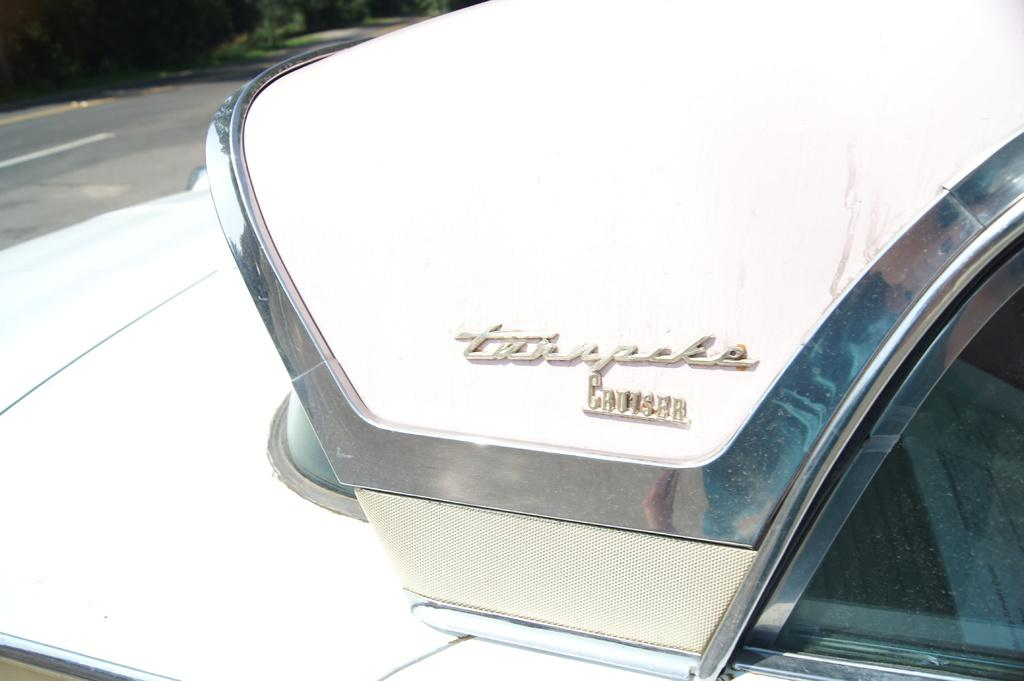What color is the vehicle in the image? The vehicle in the image is white. What can be seen on the vehicle? Something is written on the vehicle. What is visible in the background of the image? There is a road and plants visible in the background of the image. What thoughts are the plants having about the vehicle in the image? Plants do not have thoughts, so it is not possible to determine what they might be thinking about the vehicle in the image. 